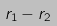<formula> <loc_0><loc_0><loc_500><loc_500>r _ { 1 } - r _ { 2 }</formula> 